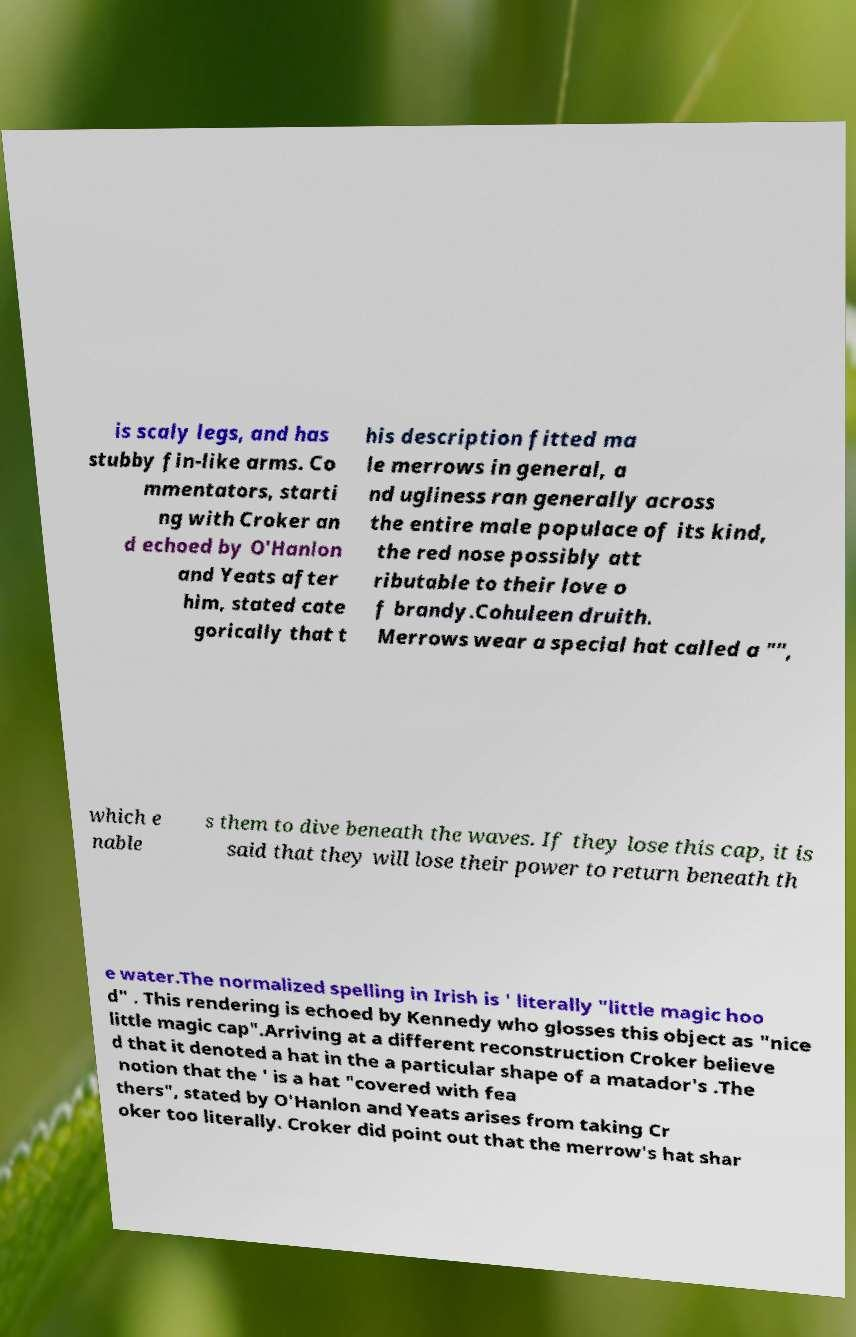Please identify and transcribe the text found in this image. is scaly legs, and has stubby fin-like arms. Co mmentators, starti ng with Croker an d echoed by O'Hanlon and Yeats after him, stated cate gorically that t his description fitted ma le merrows in general, a nd ugliness ran generally across the entire male populace of its kind, the red nose possibly att ributable to their love o f brandy.Cohuleen druith. Merrows wear a special hat called a "", which e nable s them to dive beneath the waves. If they lose this cap, it is said that they will lose their power to return beneath th e water.The normalized spelling in Irish is ' literally "little magic hoo d" . This rendering is echoed by Kennedy who glosses this object as "nice little magic cap".Arriving at a different reconstruction Croker believe d that it denoted a hat in the a particular shape of a matador's .The notion that the ' is a hat "covered with fea thers", stated by O'Hanlon and Yeats arises from taking Cr oker too literally. Croker did point out that the merrow's hat shar 